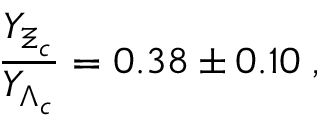Convert formula to latex. <formula><loc_0><loc_0><loc_500><loc_500>\frac { Y _ { \Xi _ { c } } } { Y _ { \Lambda _ { c } } } = 0 . 3 8 \pm 0 . 1 0 \, ,</formula> 